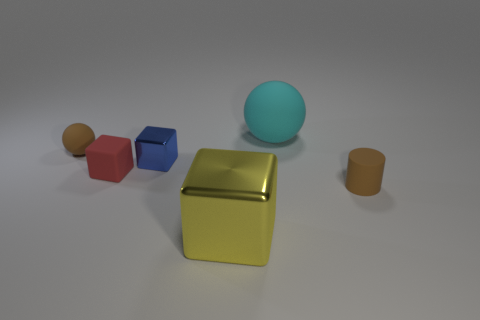Add 3 blue cubes. How many objects exist? 9 Subtract all cylinders. How many objects are left? 5 Add 3 tiny objects. How many tiny objects are left? 7 Add 1 blue blocks. How many blue blocks exist? 2 Subtract 0 green cylinders. How many objects are left? 6 Subtract all large gray shiny objects. Subtract all tiny rubber cubes. How many objects are left? 5 